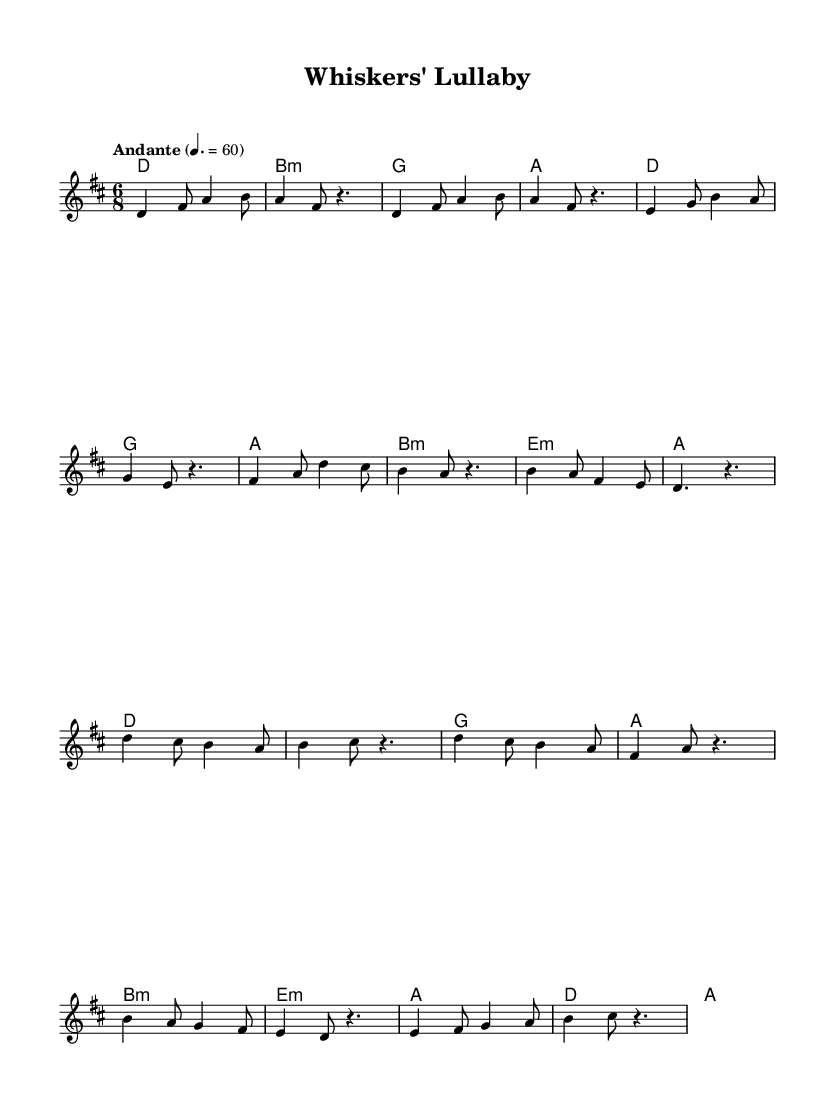What is the key signature of this music? The key signature is indicated at the beginning of the score, showing two sharps (F# and C#), which corresponds to D major.
Answer: D major What is the time signature of this music? The time signature is found in the opening measures, indicated by the notation "6/8," meaning there are six eighth notes per measure.
Answer: 6/8 What is the tempo marking for this piece? The tempo marking is located at the beginning of the score, reading "Andante" with a metronome marking of 60, indicating a moderate pace.
Answer: Andante, 60 How many measures are in the verse section? By counting the measures in the verse section, which consists of four lyrical lines, there are a total of six measures from the start of the verse to the end.
Answer: Six measures What scale degrees are primarily used in the chorus? Analyzing the chorus section, it uses the notes D, C#, B, A, and E, which correspond to the fifth, fourth, third, and second scale degrees of the D major scale.
Answer: D, C#, B, A, E What unique feature characterizes the harmony section of the music? The harmony section prominently features two minor chords (B minor and E minor) among the typical major chords, creating a sense of contrast and emotion typical of ambient-folk fusion.
Answer: Minor chords 